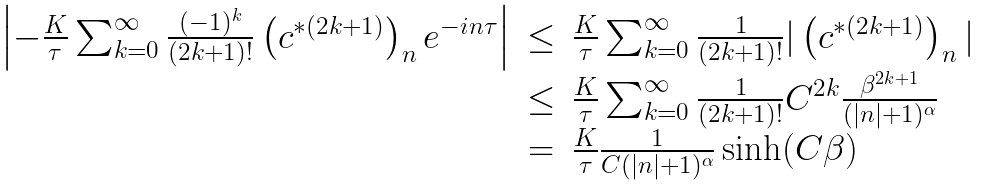Convert formula to latex. <formula><loc_0><loc_0><loc_500><loc_500>\begin{array} { r c l } \left | - \frac { K } { \tau } \sum _ { k = 0 } ^ { \infty } \frac { ( - 1 ) ^ { k } } { ( 2 k + 1 ) ! } \left ( c ^ { * ( 2 k + 1 ) } \right ) _ { n } e ^ { - i n \tau } \right | & \leq & \frac { K } { \tau } \sum _ { k = 0 } ^ { \infty } \frac { 1 } { ( 2 k + 1 ) ! } | \left ( c ^ { * ( 2 k + 1 ) } \right ) _ { n } | \\ & \leq & \frac { K } { \tau } \sum _ { k = 0 } ^ { \infty } \frac { 1 } { ( 2 k + 1 ) ! } C ^ { 2 k } \frac { \beta ^ { 2 k + 1 } } { ( | n | + 1 ) ^ { \alpha } } \\ & = & \frac { K } { \tau } \frac { 1 } { C ( | n | + 1 ) ^ { \alpha } } \sinh ( C \beta ) \end{array}</formula> 